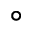<formula> <loc_0><loc_0><loc_500><loc_500>^ { \circ }</formula> 